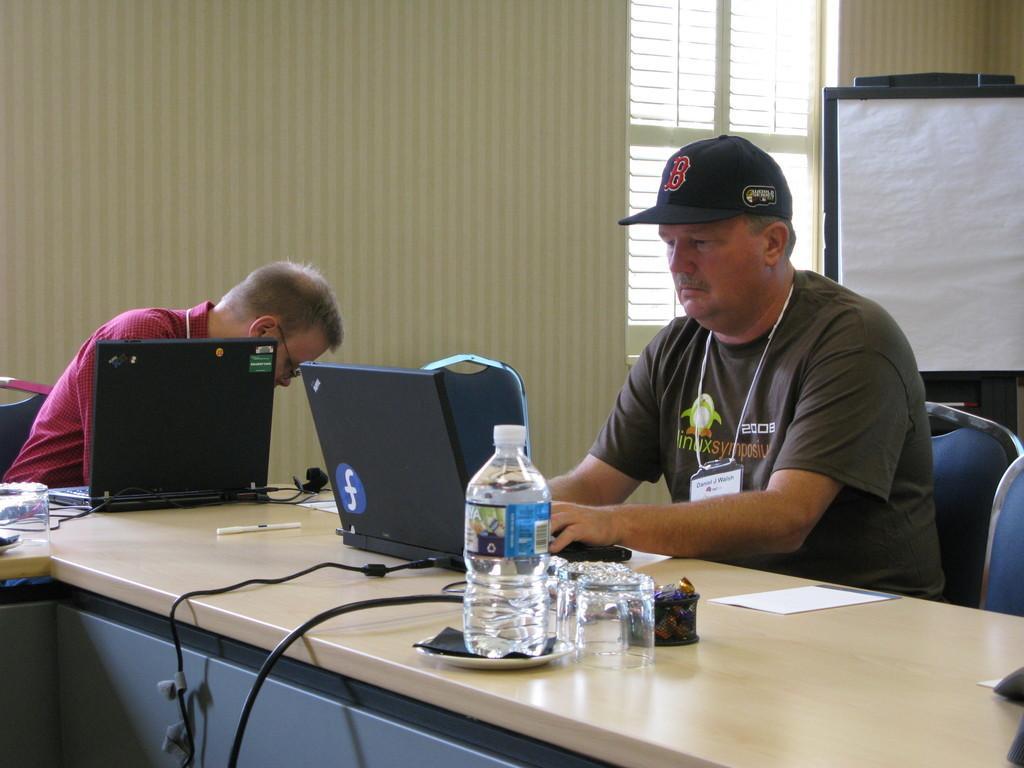Could you give a brief overview of what you see in this image? This is a picture of a man sitting in the chair and operating the laptop,another man sitting in the chair and there is a table where we have water bottle, glass and paper ,cables and at the back ground we have wall , board and a window. 